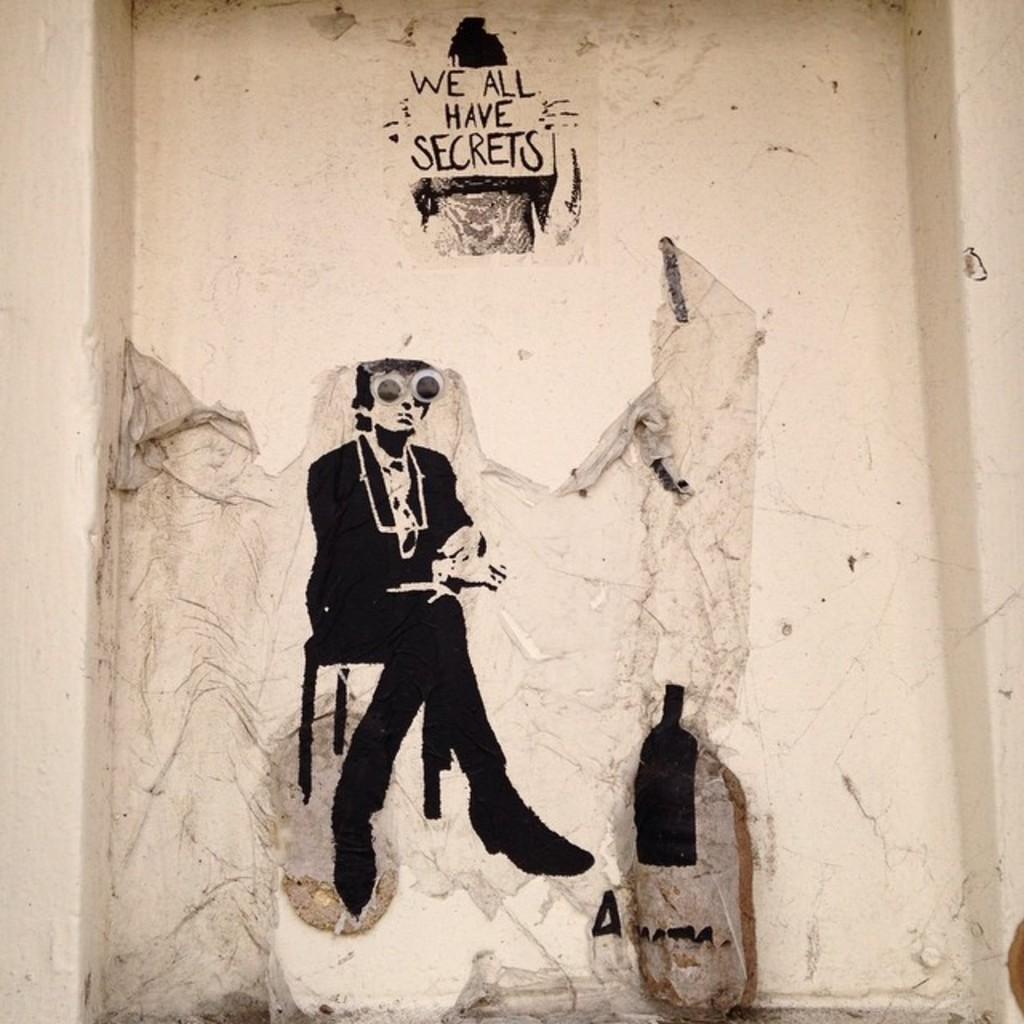What is present on the wall in the image? There are paintings and a quotation painted on the wall. Can you describe the paintings on the wall? Unfortunately, the details of the paintings cannot be determined from the image. What type of message is conveyed by the quotation on the wall? The content of the quotation cannot be determined from the image. How many beginner-level coloring books are stacked on the wall in the image? There are no coloring books present on the wall in the image. 